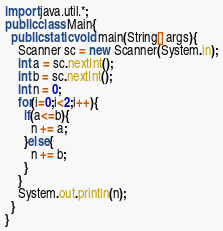Convert code to text. <code><loc_0><loc_0><loc_500><loc_500><_Java_>import java.util.*;
public class Main{
  public static void main(String[] args){
    Scanner sc = new Scanner(System.in);
    int a = sc.nextInt();
    int b = sc.nextInt();
    int n = 0;
    for(i=0;i<2;i++){
      if(a<=b){
        n += a;
      }else{
        n += b;
      }
    } 
    System.out.println(n);
  }
}





</code> 